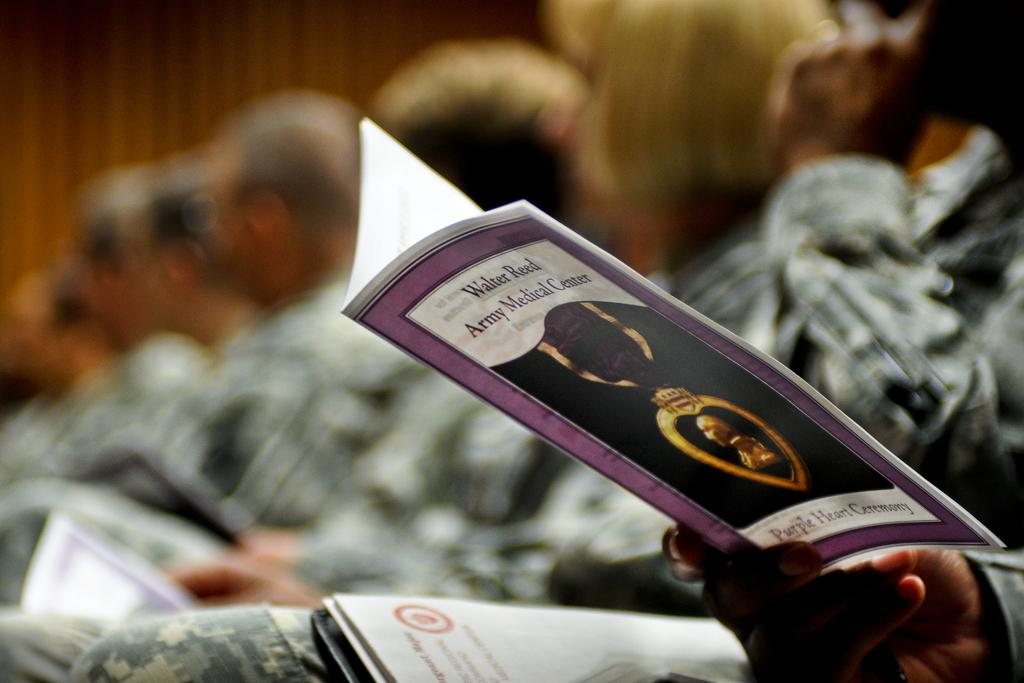<image>
Create a compact narrative representing the image presented. A group of people attend the Purple Heart ceremony for Walter Reed. 